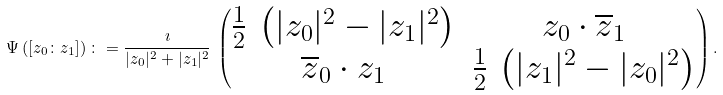<formula> <loc_0><loc_0><loc_500><loc_500>\Psi \left ( [ z _ { 0 } \colon z _ { 1 } ] \right ) \colon = \frac { \imath } { | z _ { 0 } | ^ { 2 } + | z _ { 1 } | ^ { 2 } } \, \begin{pmatrix} \frac { 1 } { 2 } \, \left ( | z _ { 0 } | ^ { 2 } - | z _ { 1 } | ^ { 2 } \right ) & z _ { 0 } \cdot \overline { z } _ { 1 } \\ \overline { z } _ { 0 } \cdot z _ { 1 } & \frac { 1 } { 2 } \, \left ( | z _ { 1 } | ^ { 2 } - | z _ { 0 } | ^ { 2 } \right ) \end{pmatrix} .</formula> 